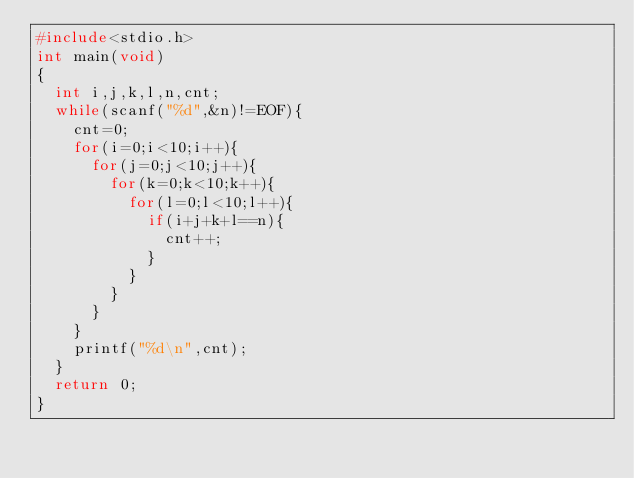Convert code to text. <code><loc_0><loc_0><loc_500><loc_500><_C_>#include<stdio.h>
int main(void)
{
	int i,j,k,l,n,cnt;
	while(scanf("%d",&n)!=EOF){
		cnt=0;
		for(i=0;i<10;i++){
			for(j=0;j<10;j++){
				for(k=0;k<10;k++){
					for(l=0;l<10;l++){
						if(i+j+k+l==n){
							cnt++;
						}
					}
				}
			}
		}
		printf("%d\n",cnt);	
	}
	return 0;
}</code> 